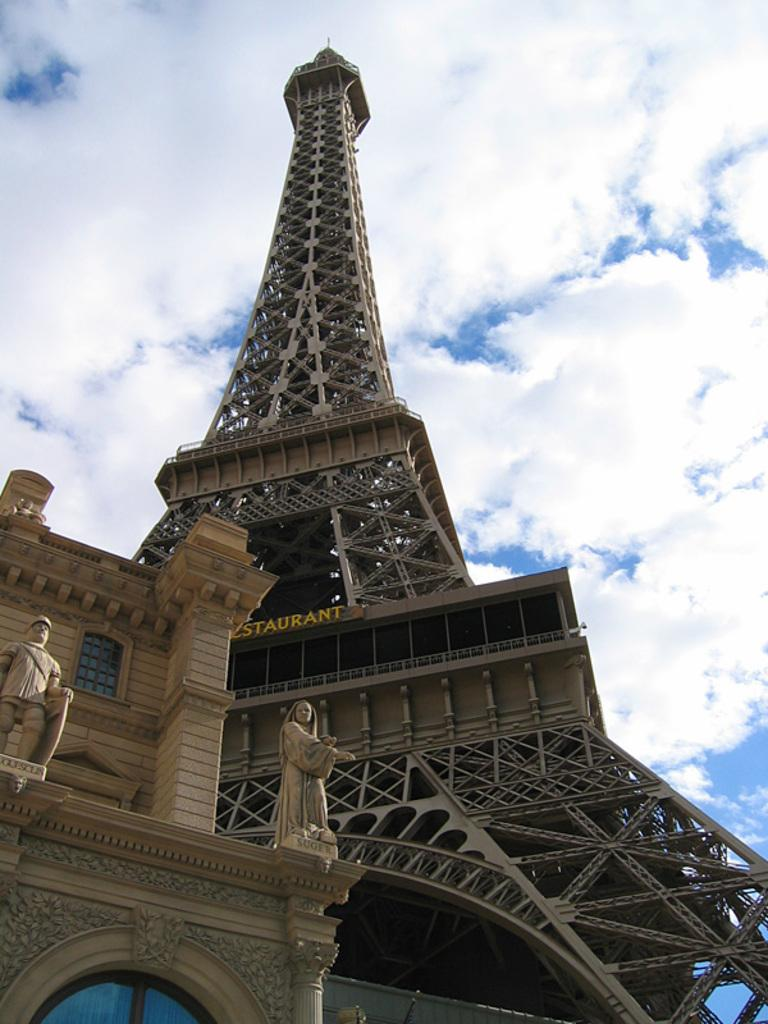What is the main subject in the center of the image? There is an Eiffel Tower in the center of the image. What can be seen on the left side of the image? There are buildings on the left side of the image. What is visible in the background of the image? There are clouds and the sky visible in the background of the image. How many cats are wearing vests while carrying a yoke in the image? There are no cats, vests, or yokes present in the image. 